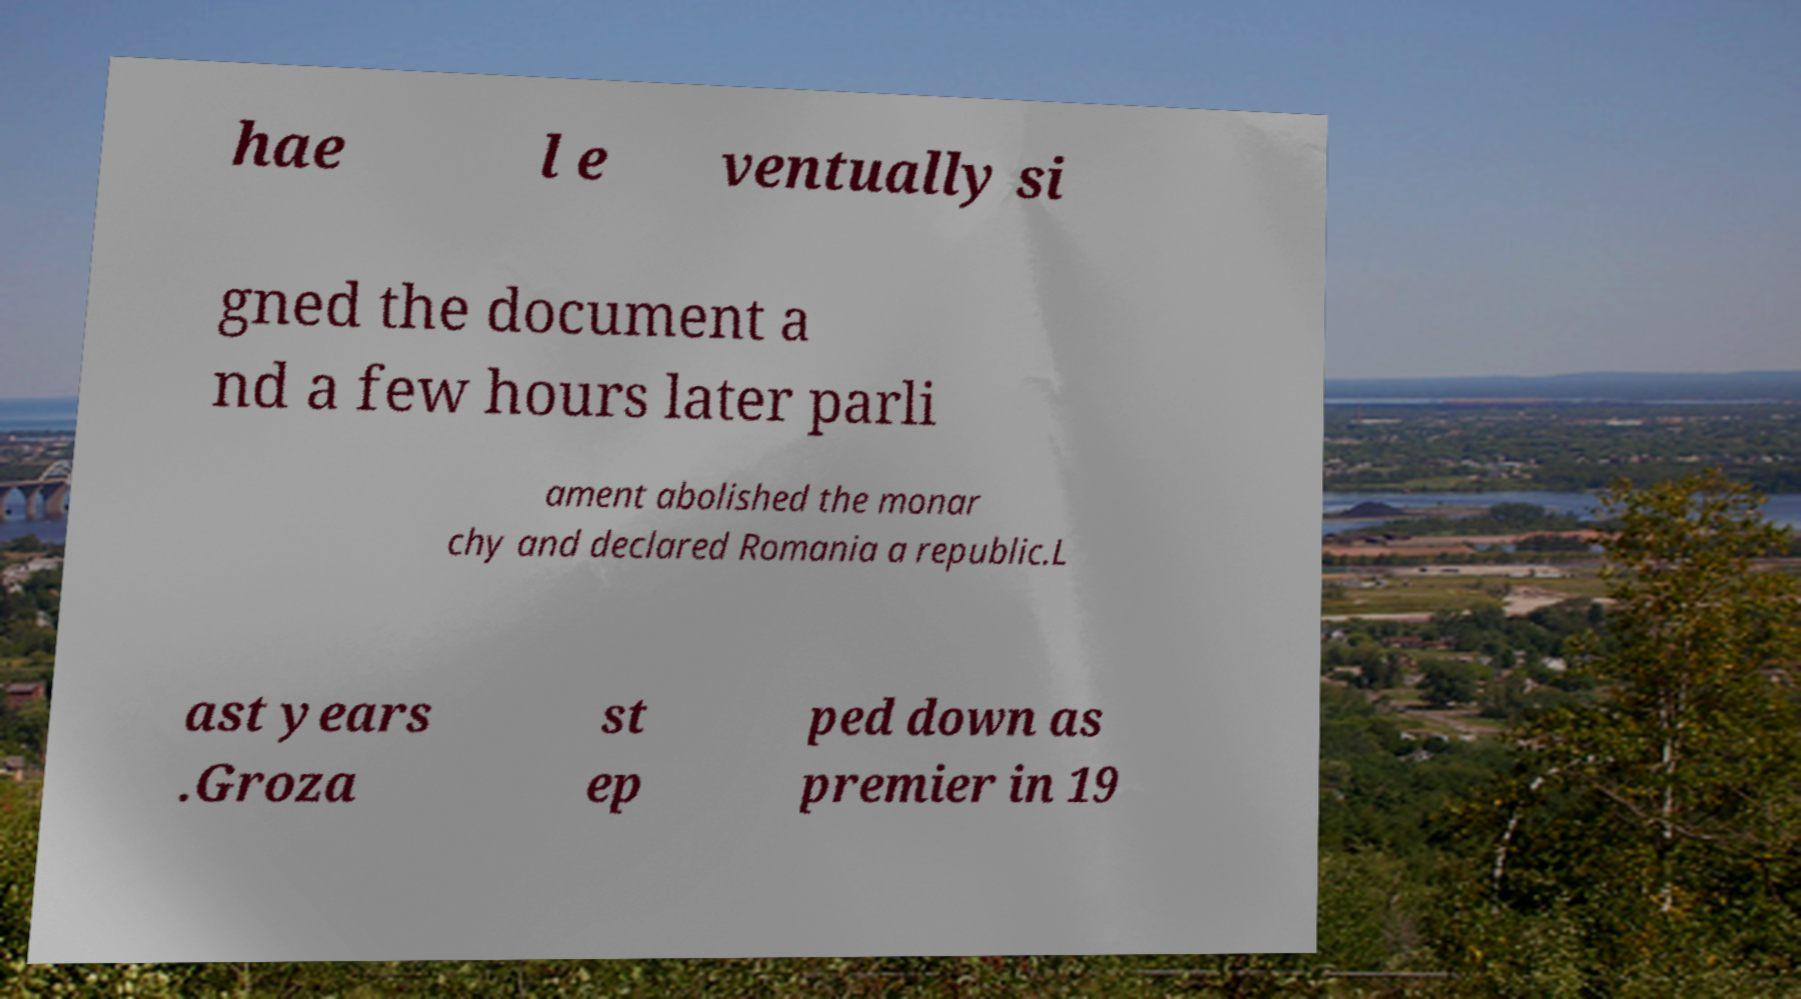Please read and relay the text visible in this image. What does it say? hae l e ventually si gned the document a nd a few hours later parli ament abolished the monar chy and declared Romania a republic.L ast years .Groza st ep ped down as premier in 19 